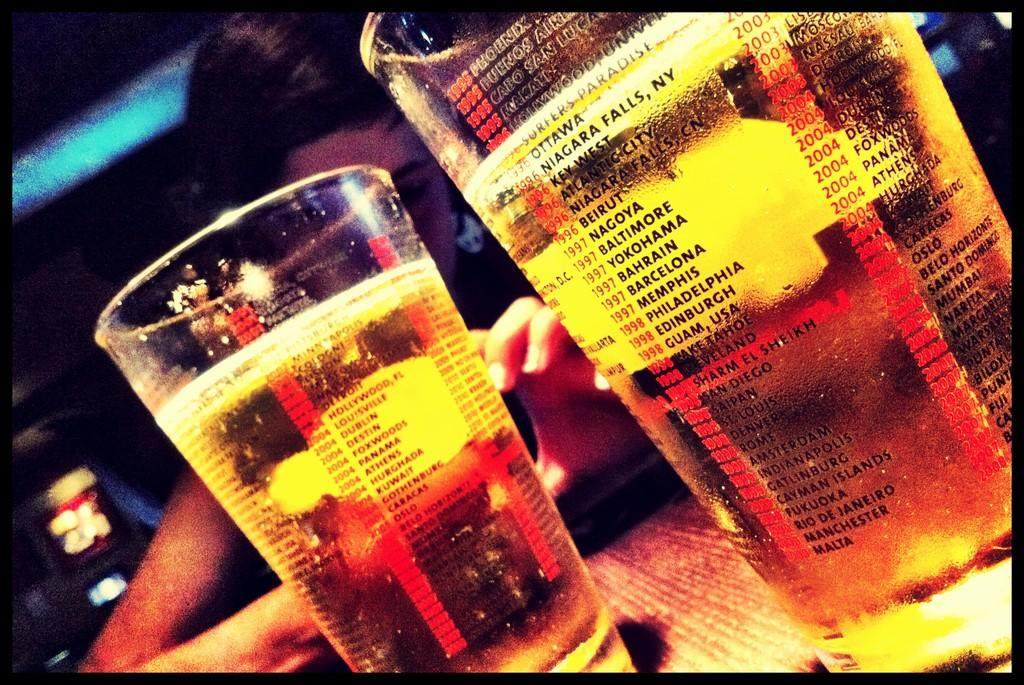<image>
Share a concise interpretation of the image provided. two cups that have lists of years and city names listed on them 